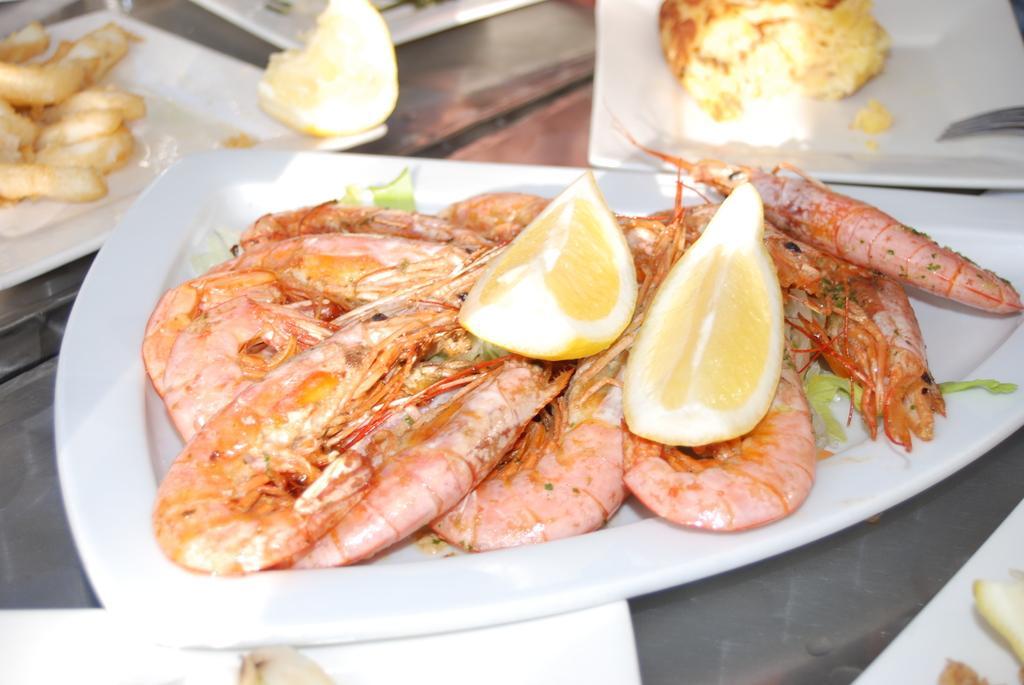Could you give a brief overview of what you see in this image? In this picture we can see some prawns and Lemons placed in the plate. Beside there are some white plates and food. 